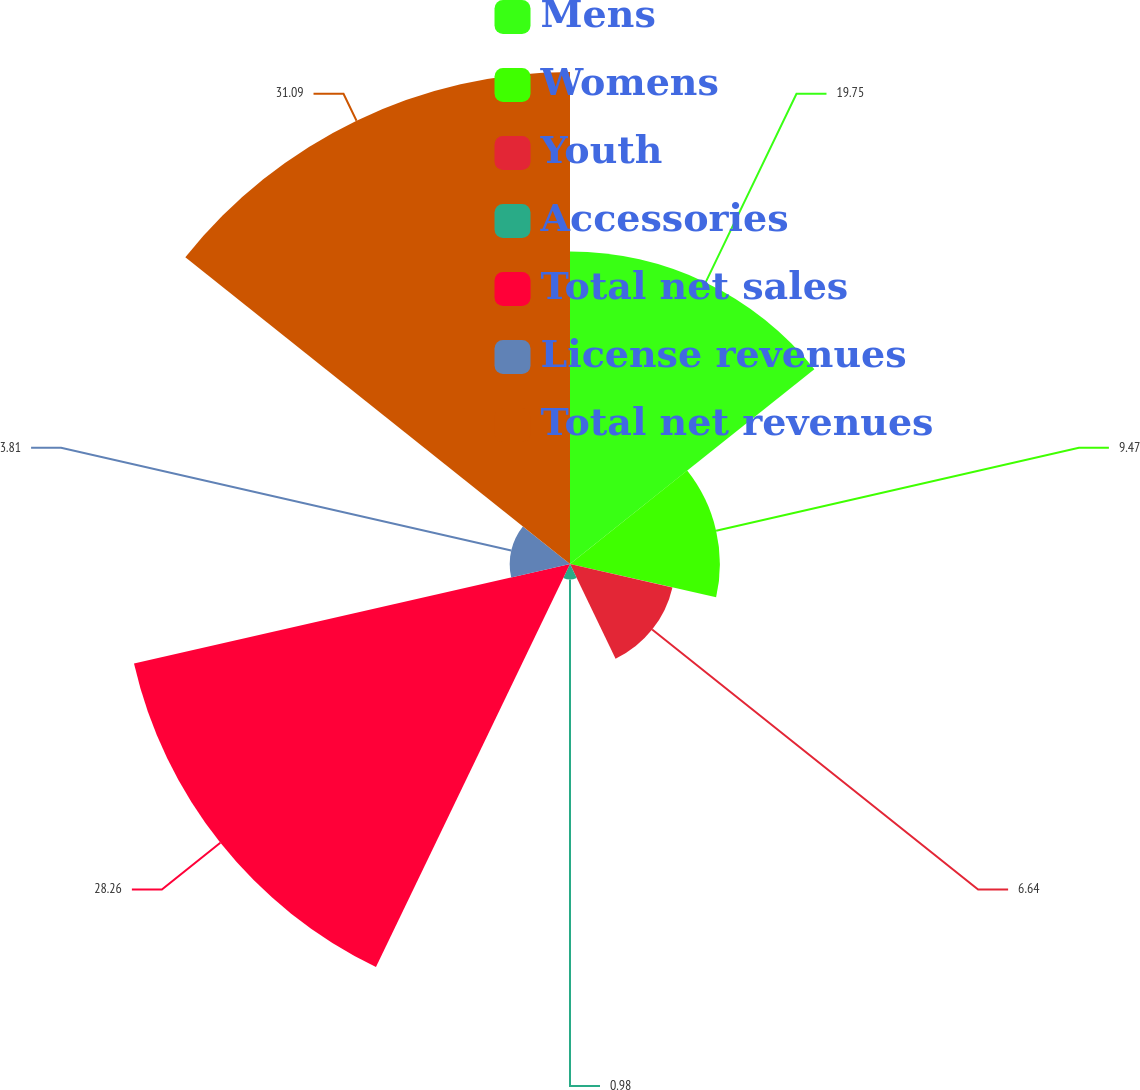Convert chart. <chart><loc_0><loc_0><loc_500><loc_500><pie_chart><fcel>Mens<fcel>Womens<fcel>Youth<fcel>Accessories<fcel>Total net sales<fcel>License revenues<fcel>Total net revenues<nl><fcel>19.75%<fcel>9.47%<fcel>6.64%<fcel>0.98%<fcel>28.26%<fcel>3.81%<fcel>31.09%<nl></chart> 